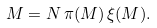Convert formula to latex. <formula><loc_0><loc_0><loc_500><loc_500>M = N \, \pi ( M ) \, \xi ( M ) .</formula> 